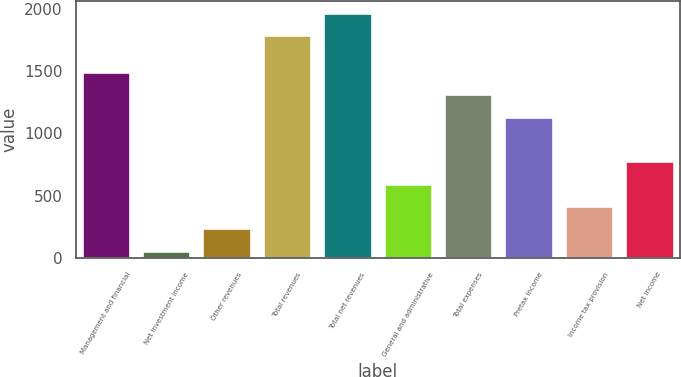Convert chart to OTSL. <chart><loc_0><loc_0><loc_500><loc_500><bar_chart><fcel>Management and financial<fcel>Net investment income<fcel>Other revenues<fcel>Total revenues<fcel>Total net revenues<fcel>General and administrative<fcel>Total expenses<fcel>Pretax income<fcel>Income tax provision<fcel>Net income<nl><fcel>1492.4<fcel>58<fcel>237.3<fcel>1786<fcel>1965.3<fcel>595.9<fcel>1313.1<fcel>1133.8<fcel>416.6<fcel>775.2<nl></chart> 